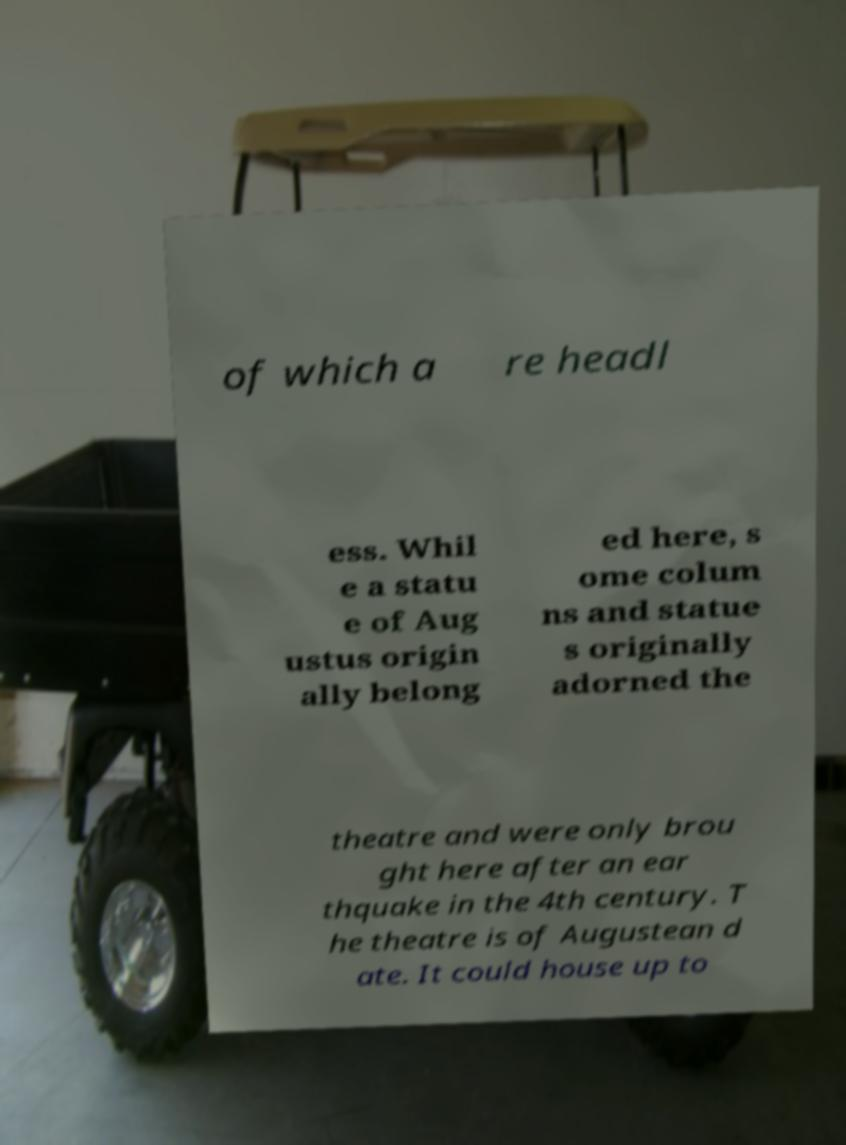Can you accurately transcribe the text from the provided image for me? of which a re headl ess. Whil e a statu e of Aug ustus origin ally belong ed here, s ome colum ns and statue s originally adorned the theatre and were only brou ght here after an ear thquake in the 4th century. T he theatre is of Augustean d ate. It could house up to 